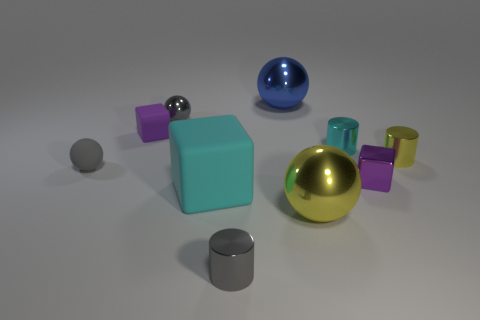Is the material of the blue object the same as the small cylinder right of the tiny cyan metal thing?
Your answer should be very brief. Yes. The tiny metal object that is behind the yellow sphere and left of the small cyan cylinder is what color?
Your response must be concise. Gray. What number of cylinders are cyan shiny things or gray metallic objects?
Keep it short and to the point. 2. Do the large yellow object and the gray metal object to the left of the big rubber object have the same shape?
Give a very brief answer. Yes. There is a thing that is both to the right of the blue thing and in front of the cyan matte thing; what is its size?
Provide a short and direct response. Large. What is the shape of the cyan shiny thing?
Your response must be concise. Cylinder. There is a metal cylinder that is left of the big blue metal sphere; is there a tiny rubber thing in front of it?
Your response must be concise. No. How many tiny cyan metal things are behind the gray sphere right of the matte ball?
Provide a short and direct response. 0. What material is the cyan cylinder that is the same size as the purple metallic cube?
Give a very brief answer. Metal. There is a small thing that is in front of the big yellow object; is it the same shape as the blue object?
Provide a short and direct response. No. 